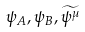Convert formula to latex. <formula><loc_0><loc_0><loc_500><loc_500>\psi _ { A } , \psi _ { B } , \widetilde { \psi ^ { \mu } }</formula> 